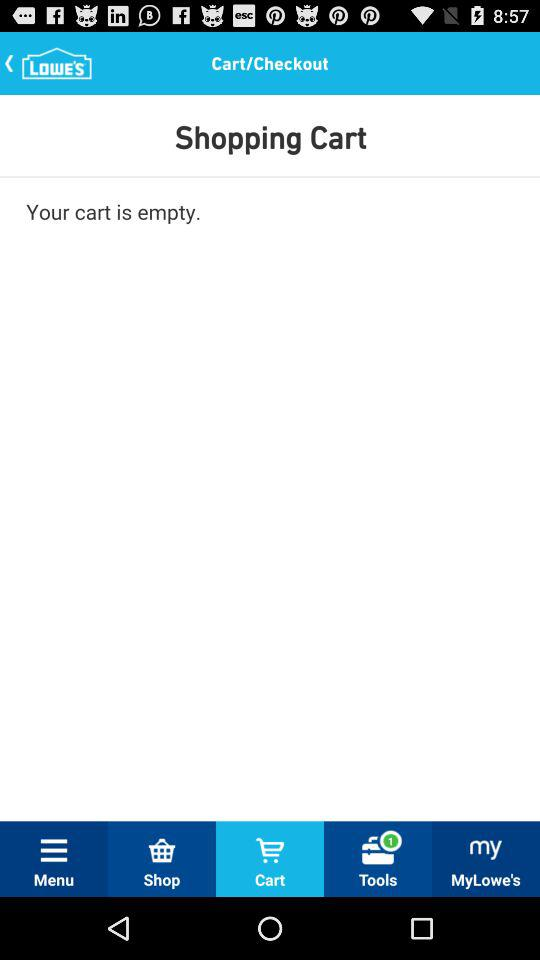How many unread notifications are there in the tools tab? There is only one unread notification. 